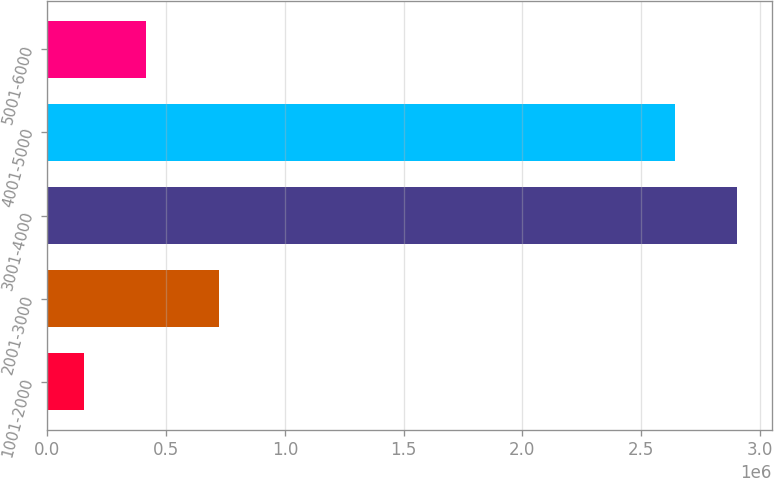Convert chart. <chart><loc_0><loc_0><loc_500><loc_500><bar_chart><fcel>1001-2000<fcel>2001-3000<fcel>3001-4000<fcel>4001-5000<fcel>5001-6000<nl><fcel>154803<fcel>723172<fcel>2.90647e+06<fcel>2.64578e+06<fcel>415499<nl></chart> 